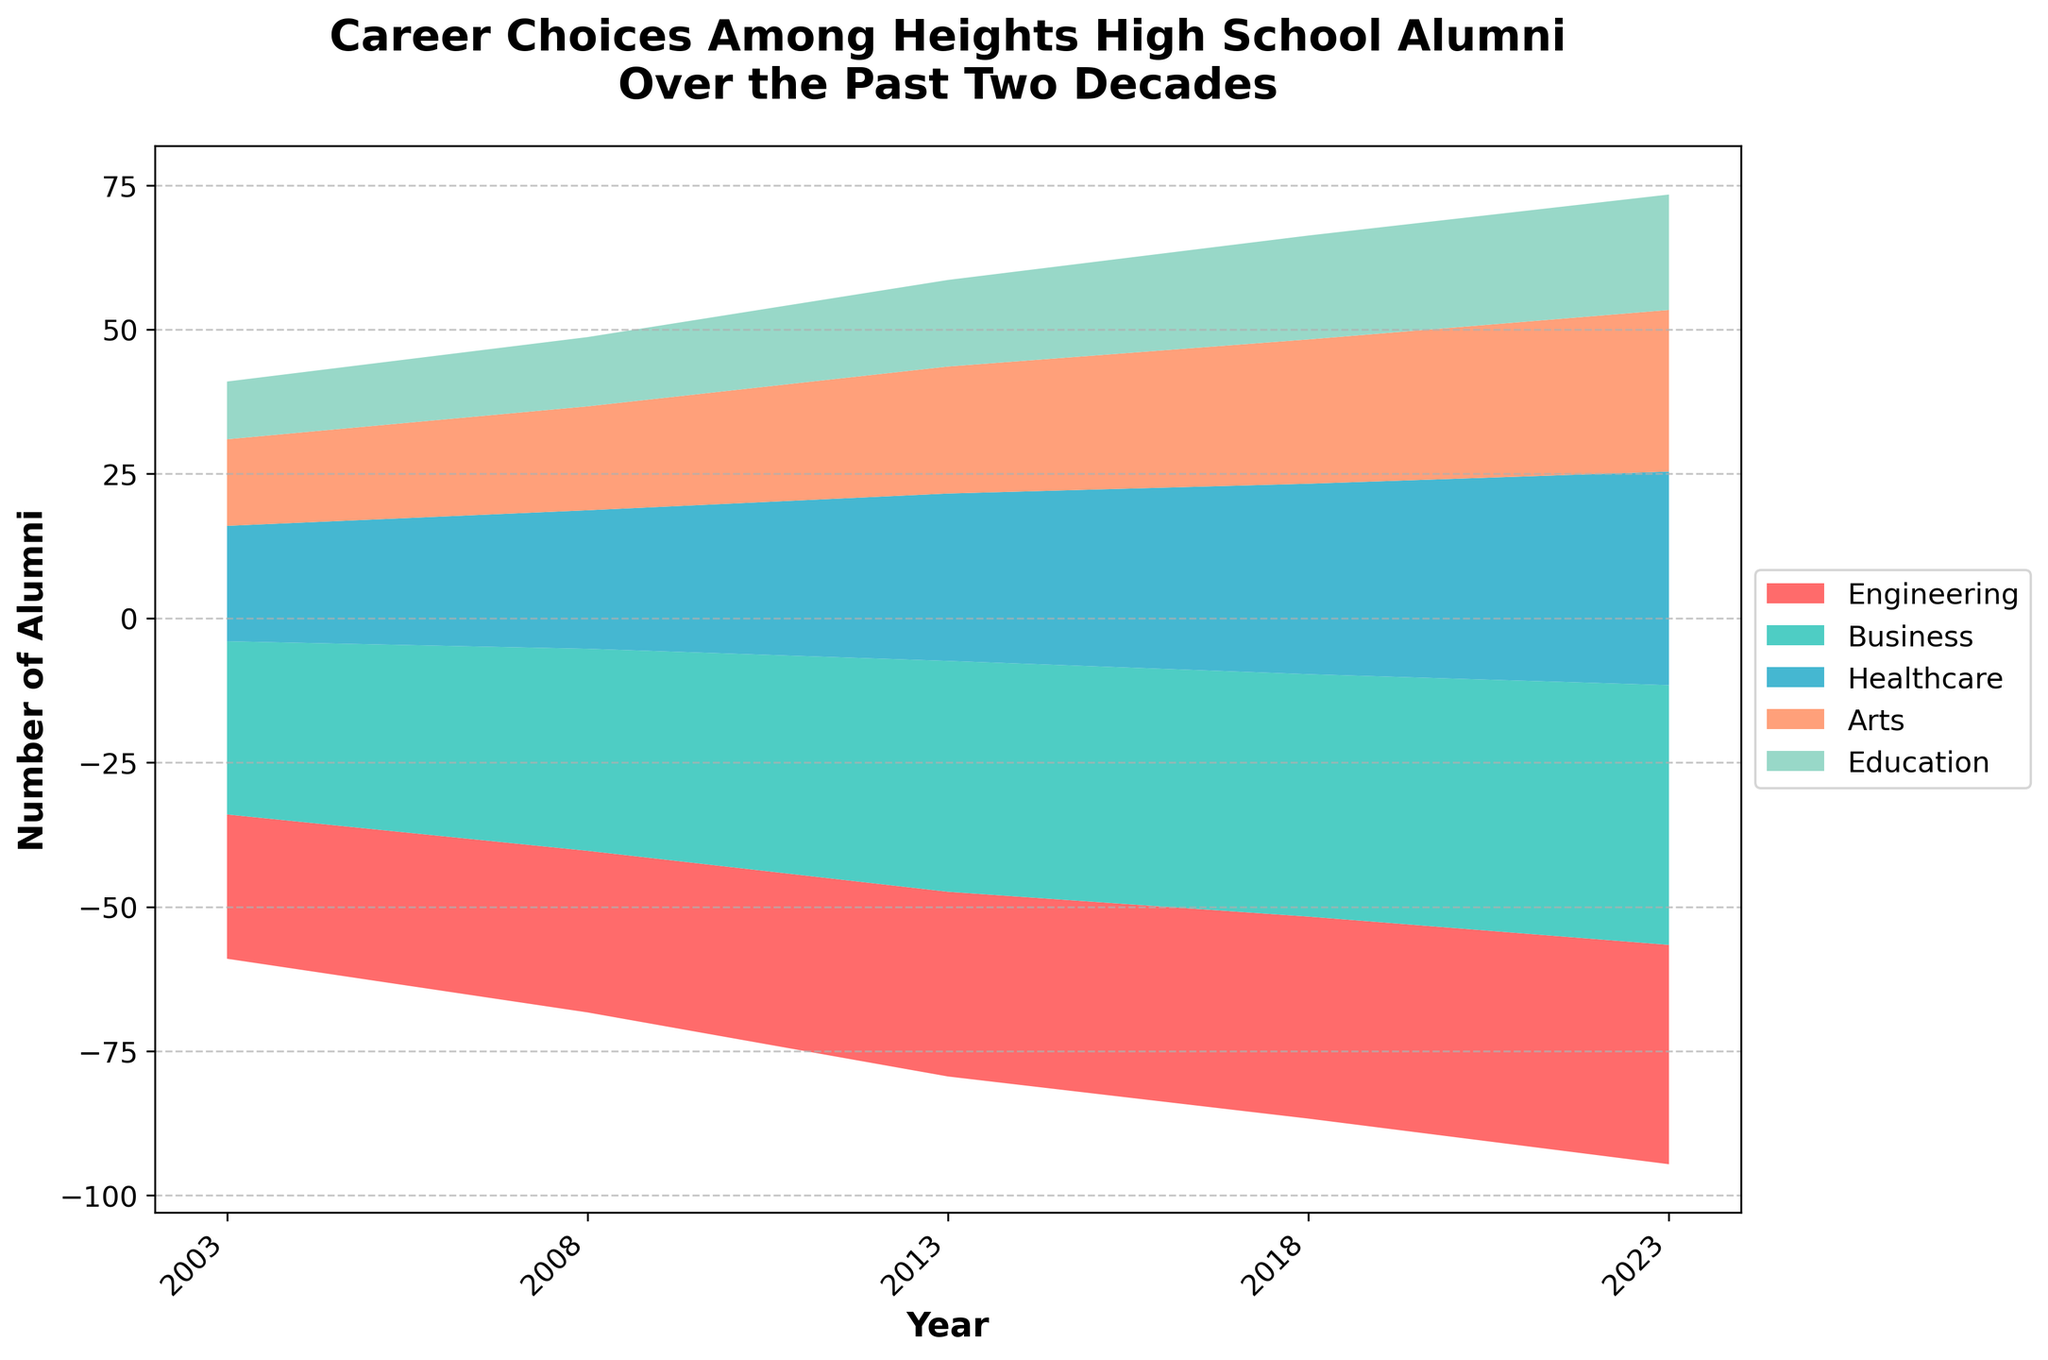What's the title of the figure? The title is usually located at the top of the figure and is used to describe what the figure represents. Here, the title clearly states "Career Choices Among Heights High School Alumni Over the Past Two Decades."
Answer: Career Choices Among Heights High School Alumni Over the Past Two Decades How many fields of study are represented in the figure? The fields of study can be identified by looking at the legend on the right side of the figure, which lists all the categories included. There are five in total: Engineering, Business, Healthcare, Arts, and Education.
Answer: Five Which field had the highest number of alumni in 2023? To determine the field with the highest number of alumni in 2023, look at the streams at the rightmost side of the graph, which corresponds to 2023, and find the one with the greatest width. The Business field has the widest stream, indicating the highest number of alumni.
Answer: Business What is the trend for alumni in Healthcare over the two decades? By following the stream for Healthcare from 2003 to 2023, we can observe whether it is generally increasing, decreasing, or remaining stable. The trend shows a steady increase in the number of alumni in Healthcare over the years.
Answer: Increasing How many alumni were in the Engineering field in 2013? To find this, identify the Engineering stream in the figure and follow it to the point corresponding to the year 2013. The figure indicates that there were 32 alumni in the Engineering field in 2013.
Answer: 32 Which year shows the highest total number of alumni across all fields? To find this, we sum the number of alumni for all fields in each year and compare. The years are represented on the x-axis, and the area under the streams for each year represents the total number. The plot shows that 2023 had the highest total number of alumni.
Answer: 2023 What is the difference in the number of alumni between Business and Arts in 2018? First, find the number of alumni in Business (42) and Arts (25) for 2018 by following their respective streams. Then, subtract the number of alumni in Arts from the number in Business: 42 - 25 = 17.
Answer: 17 Has the number of alumni in Education ever surpassed that in Engineering in any given year? Follow the streams for both Education and Engineering across all years and compare their widths. At no point does the stream for Education surpass the stream for Engineering.
Answer: No What is the average number of alumni in the Business field over the five given years? Add the number of alumni in Business for each year and divide by the number of years: (30 + 35 + 40 + 42 + 45) / 5 = 192/5 = 38.4.
Answer: 38.4 What pattern can be observed between the fields of Arts and Education over the years? By comparing the streams for Arts and Education from 2003 to 2023, we can observe that both show a gradual increase, however, the number of alumni in Arts consistently remains higher than in Education throughout the period.
Answer: Arts consistently higher 